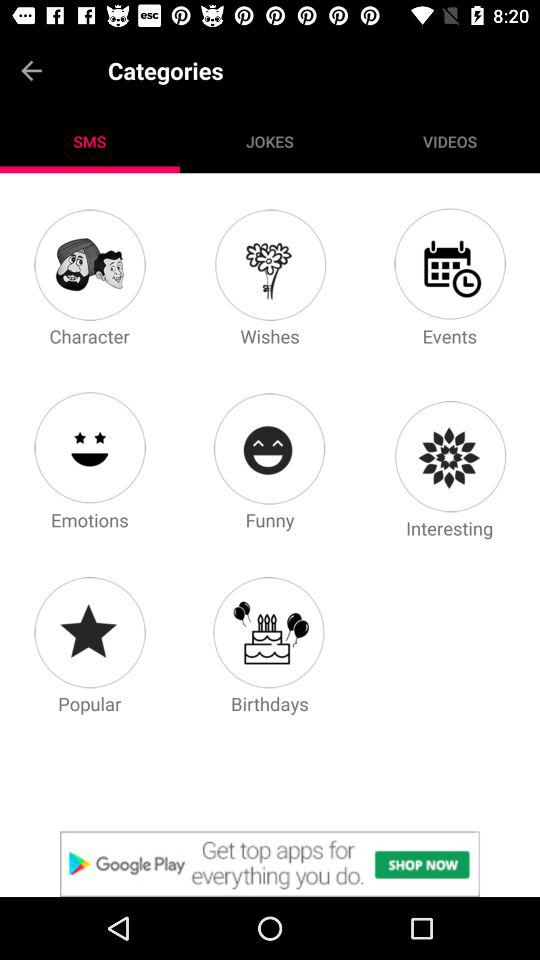How many character SMS are there?
When the provided information is insufficient, respond with <no answer>. <no answer> 